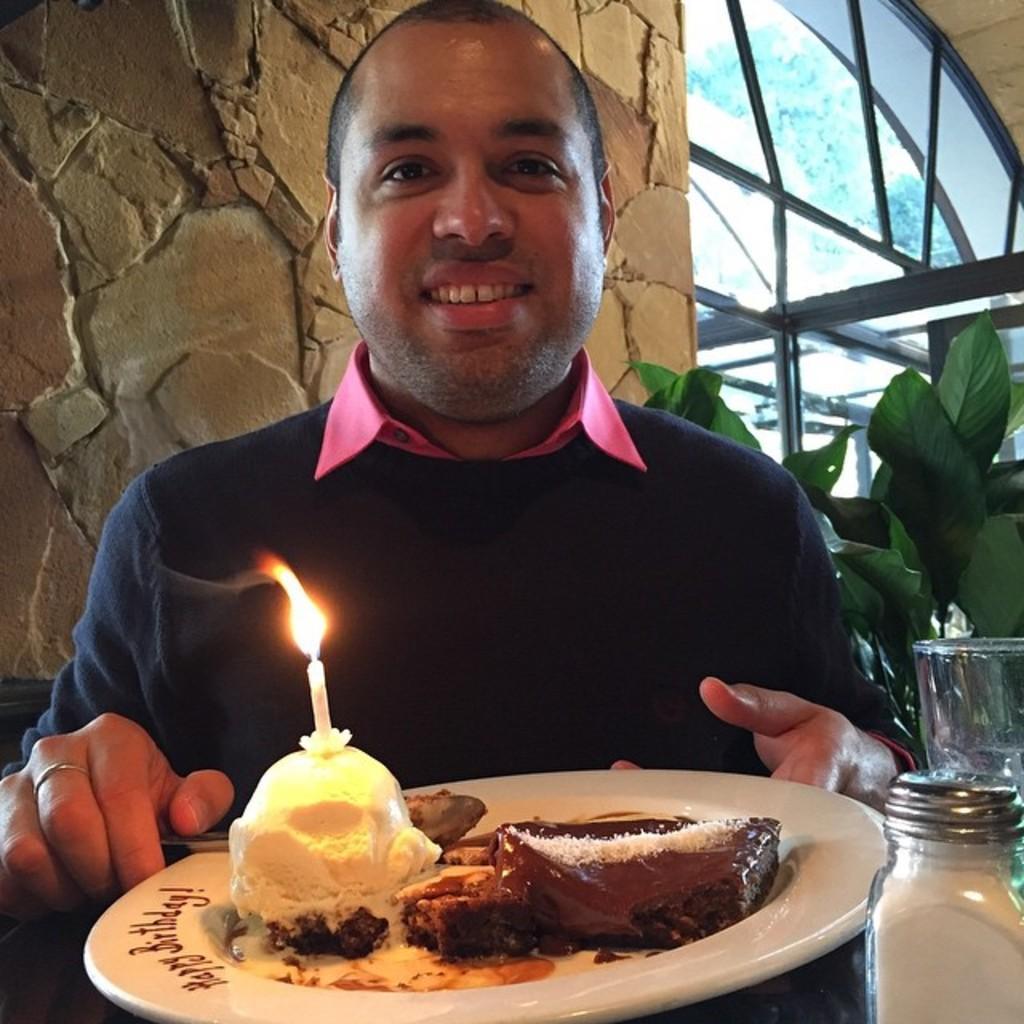How would you summarize this image in a sentence or two? In this image I can see a man is smiling. Here I can see a plate which has food items on it. I can also see a candle on the food item. Here I can see some other objects on the table. In the background I can see a plant and a wall. 